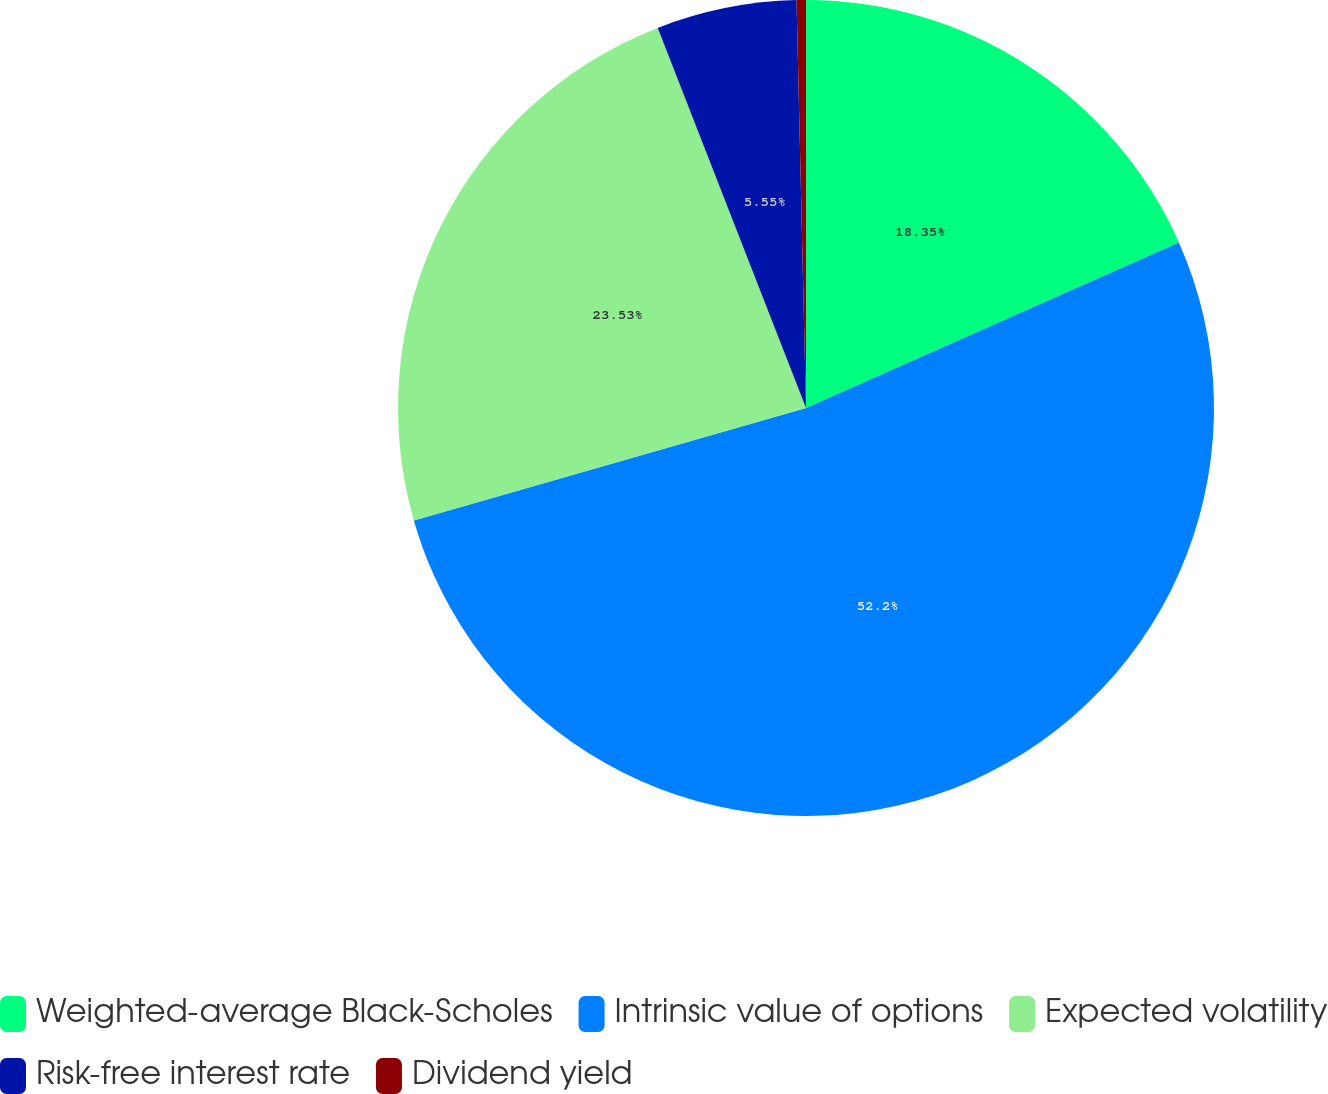<chart> <loc_0><loc_0><loc_500><loc_500><pie_chart><fcel>Weighted-average Black-Scholes<fcel>Intrinsic value of options<fcel>Expected volatility<fcel>Risk-free interest rate<fcel>Dividend yield<nl><fcel>18.35%<fcel>52.21%<fcel>23.53%<fcel>5.55%<fcel>0.37%<nl></chart> 